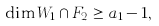<formula> <loc_0><loc_0><loc_500><loc_500>\dim W _ { 1 } \cap F _ { 2 } \geq a _ { 1 } - 1 ,</formula> 